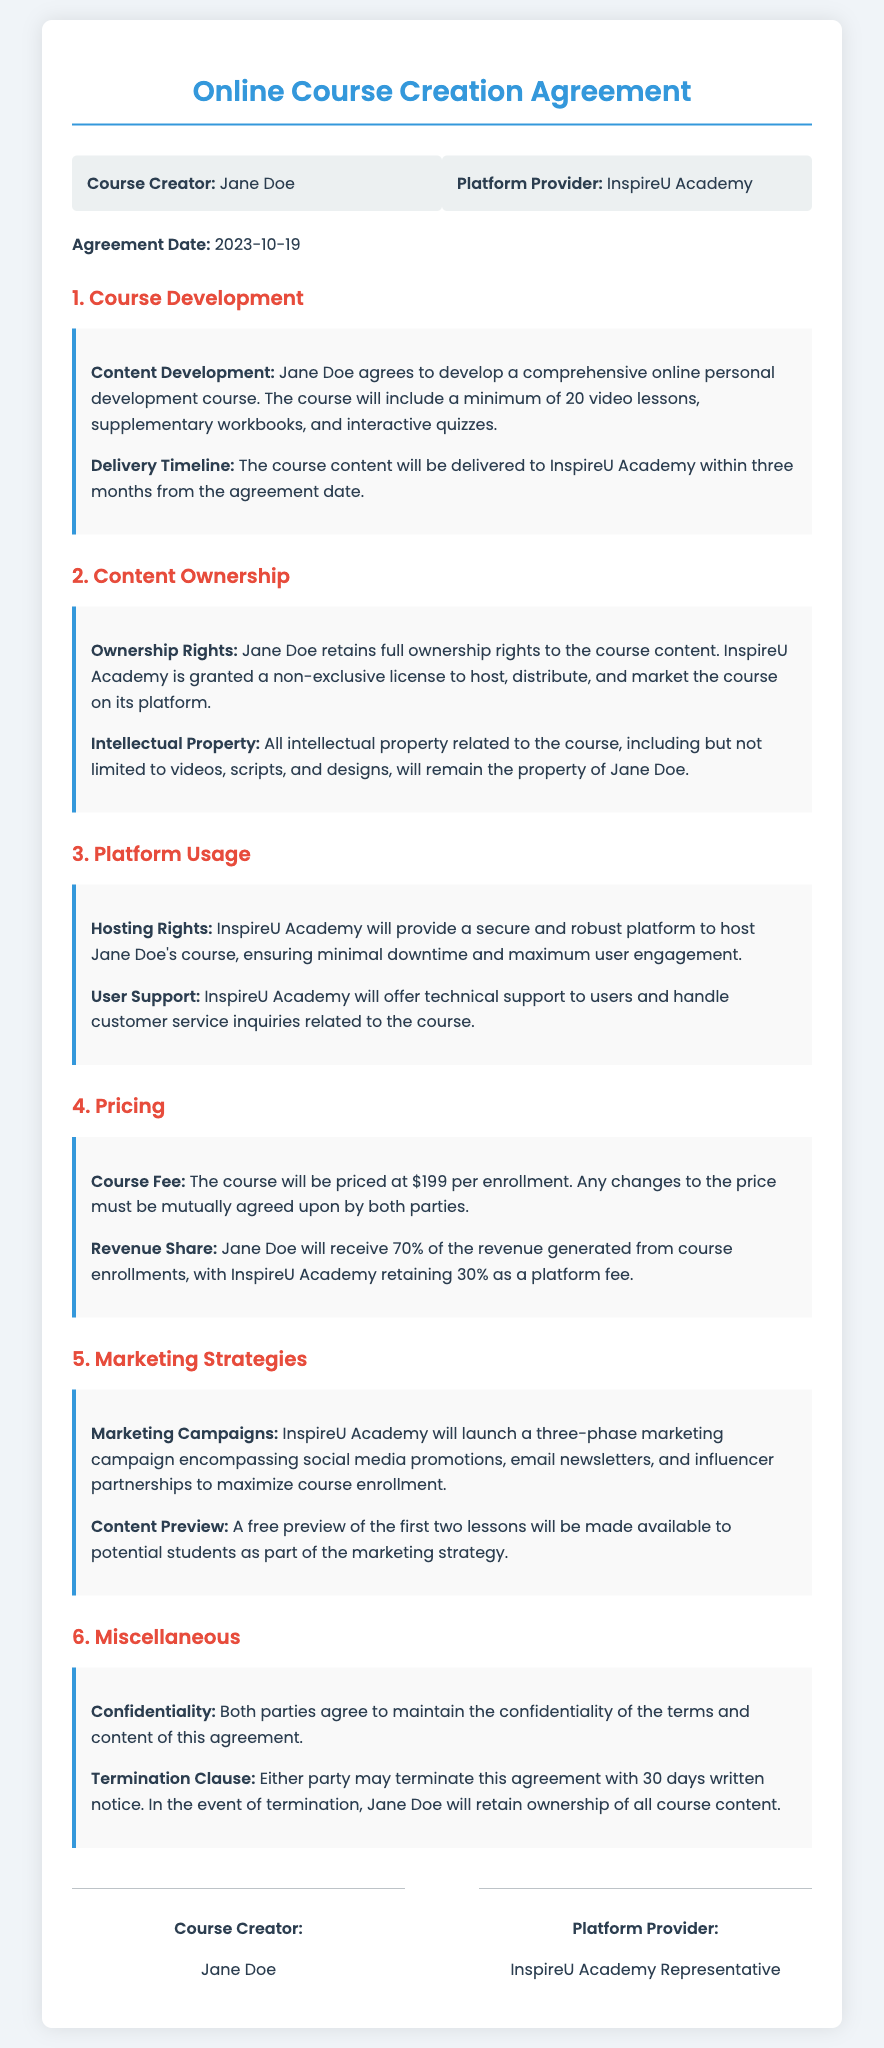What is the agreement date? The agreement date is specified in the document, indicating when the parties reached the agreement.
Answer: 2023-10-19 Who is the Course Creator? The Course Creator's name is listed at the beginning of the document as the individual responsible for course content.
Answer: Jane Doe What is the course fee? The document outlines the pricing for the online personal development course, indicating how much users will need to pay to enroll.
Answer: $199 What percentage of revenue does Jane Doe receive? The revenue share section discusses the distribution of income generated from course enrollments, specifying Jane Doe's portion.
Answer: 70% How long is the delivery timeline for course content? The delivery timeline specifies the time frame within which the course content needs to be delivered to the Platform Provider.
Answer: three months What marketing strategies will be employed? The document describes the marketing approach that will be used to promote the course, focusing on specific campaigns.
Answer: three-phase marketing campaign What will happen if the agreement is terminated? The termination clause outlines the procedure and the implications if one party decides to end the agreement.
Answer: Jane Doe will retain ownership of all course content 